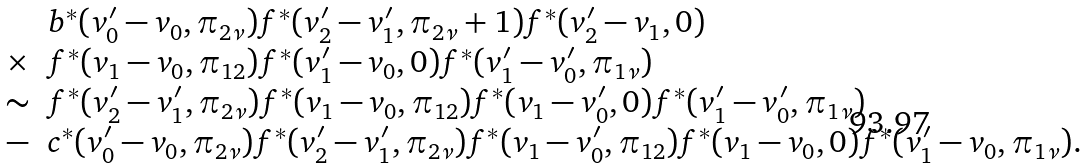Convert formula to latex. <formula><loc_0><loc_0><loc_500><loc_500>\begin{array} { c l } & b ^ { * } ( v ^ { \prime } _ { 0 } - v _ { 0 } , \pi _ { 2 \nu } ) f ^ { * } ( v ^ { \prime } _ { 2 } - v ^ { \prime } _ { 1 } , \pi _ { 2 \nu } + 1 ) f ^ { * } ( v ^ { \prime } _ { 2 } - v _ { 1 } , 0 ) \\ \times & f ^ { * } ( v _ { 1 } - v _ { 0 } , \pi _ { 1 2 } ) f ^ { * } ( v ^ { \prime } _ { 1 } - v _ { 0 } , 0 ) f ^ { * } ( v ^ { \prime } _ { 1 } - v ^ { \prime } _ { 0 } , \pi _ { 1 \nu } ) \\ \sim & f ^ { * } ( v ^ { \prime } _ { 2 } - v ^ { \prime } _ { 1 } , \pi _ { 2 \nu } ) f ^ { * } ( v _ { 1 } - v _ { 0 } , \pi _ { 1 2 } ) f ^ { * } ( v _ { 1 } - v ^ { \prime } _ { 0 } , 0 ) f ^ { * } ( v ^ { \prime } _ { 1 } - v ^ { \prime } _ { 0 } , \pi _ { 1 \nu } ) \\ - & c ^ { * } ( v ^ { \prime } _ { 0 } - v _ { 0 } , \pi _ { 2 \nu } ) f ^ { * } ( v ^ { \prime } _ { 2 } - v ^ { \prime } _ { 1 } , \pi _ { 2 \nu } ) f ^ { * } ( v _ { 1 } - v ^ { \prime } _ { 0 } , \pi _ { 1 2 } ) f ^ { * } ( v _ { 1 } - v _ { 0 } , 0 ) f ^ { * } ( v ^ { \prime } _ { 1 } - v _ { 0 } , \pi _ { 1 \nu } ) . \end{array}</formula> 